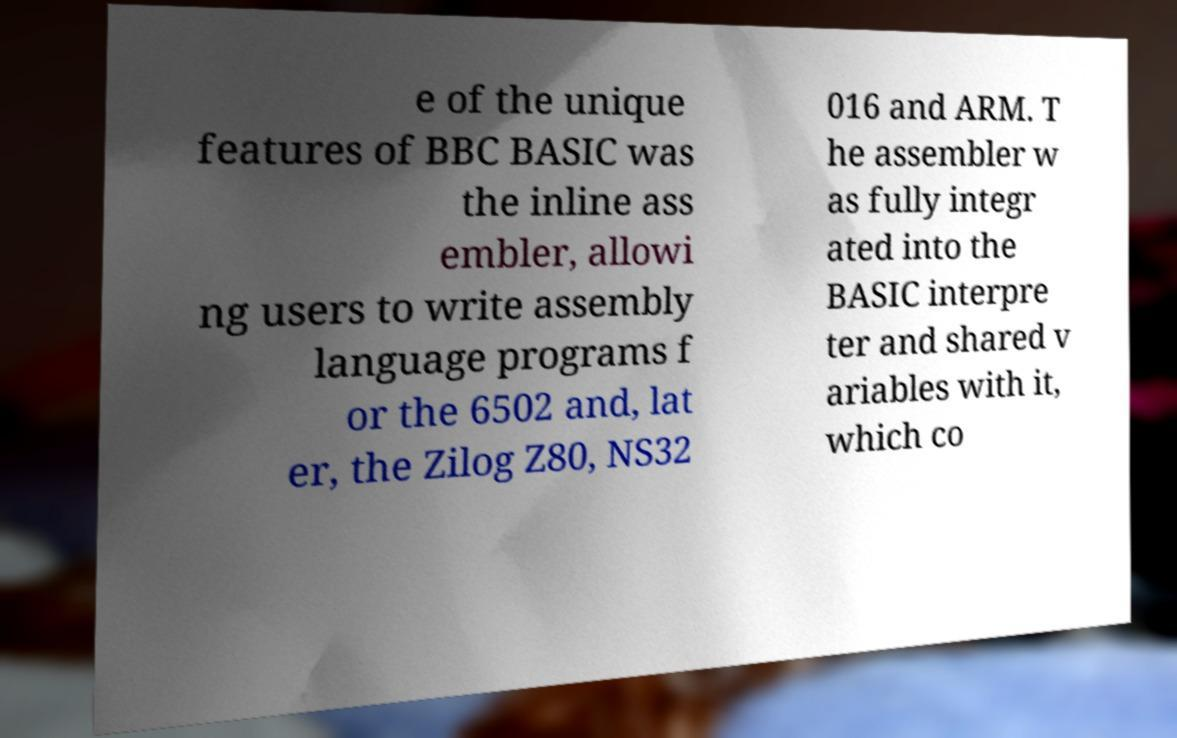Can you read and provide the text displayed in the image?This photo seems to have some interesting text. Can you extract and type it out for me? e of the unique features of BBC BASIC was the inline ass embler, allowi ng users to write assembly language programs f or the 6502 and, lat er, the Zilog Z80, NS32 016 and ARM. T he assembler w as fully integr ated into the BASIC interpre ter and shared v ariables with it, which co 